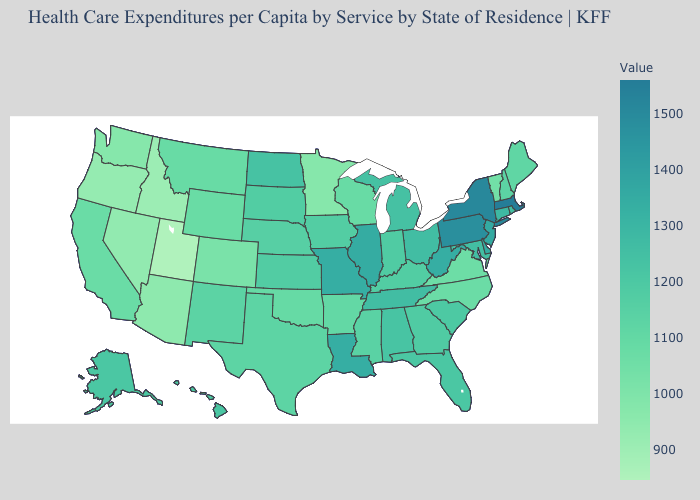Does the map have missing data?
Answer briefly. No. Does Ohio have a lower value than Colorado?
Give a very brief answer. No. Which states have the lowest value in the West?
Give a very brief answer. Utah. Which states have the lowest value in the USA?
Be succinct. Utah. Does Mississippi have the highest value in the South?
Quick response, please. No. Is the legend a continuous bar?
Be succinct. Yes. Which states have the lowest value in the Northeast?
Be succinct. Vermont. Among the states that border Missouri , does Tennessee have the highest value?
Short answer required. No. 